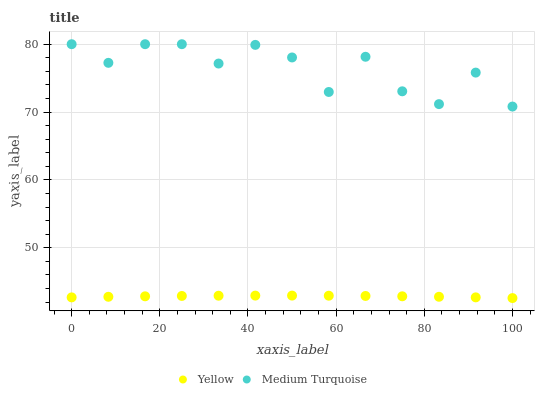Does Yellow have the minimum area under the curve?
Answer yes or no. Yes. Does Medium Turquoise have the maximum area under the curve?
Answer yes or no. Yes. Does Yellow have the maximum area under the curve?
Answer yes or no. No. Is Yellow the smoothest?
Answer yes or no. Yes. Is Medium Turquoise the roughest?
Answer yes or no. Yes. Is Yellow the roughest?
Answer yes or no. No. Does Yellow have the lowest value?
Answer yes or no. Yes. Does Medium Turquoise have the highest value?
Answer yes or no. Yes. Does Yellow have the highest value?
Answer yes or no. No. Is Yellow less than Medium Turquoise?
Answer yes or no. Yes. Is Medium Turquoise greater than Yellow?
Answer yes or no. Yes. Does Yellow intersect Medium Turquoise?
Answer yes or no. No. 